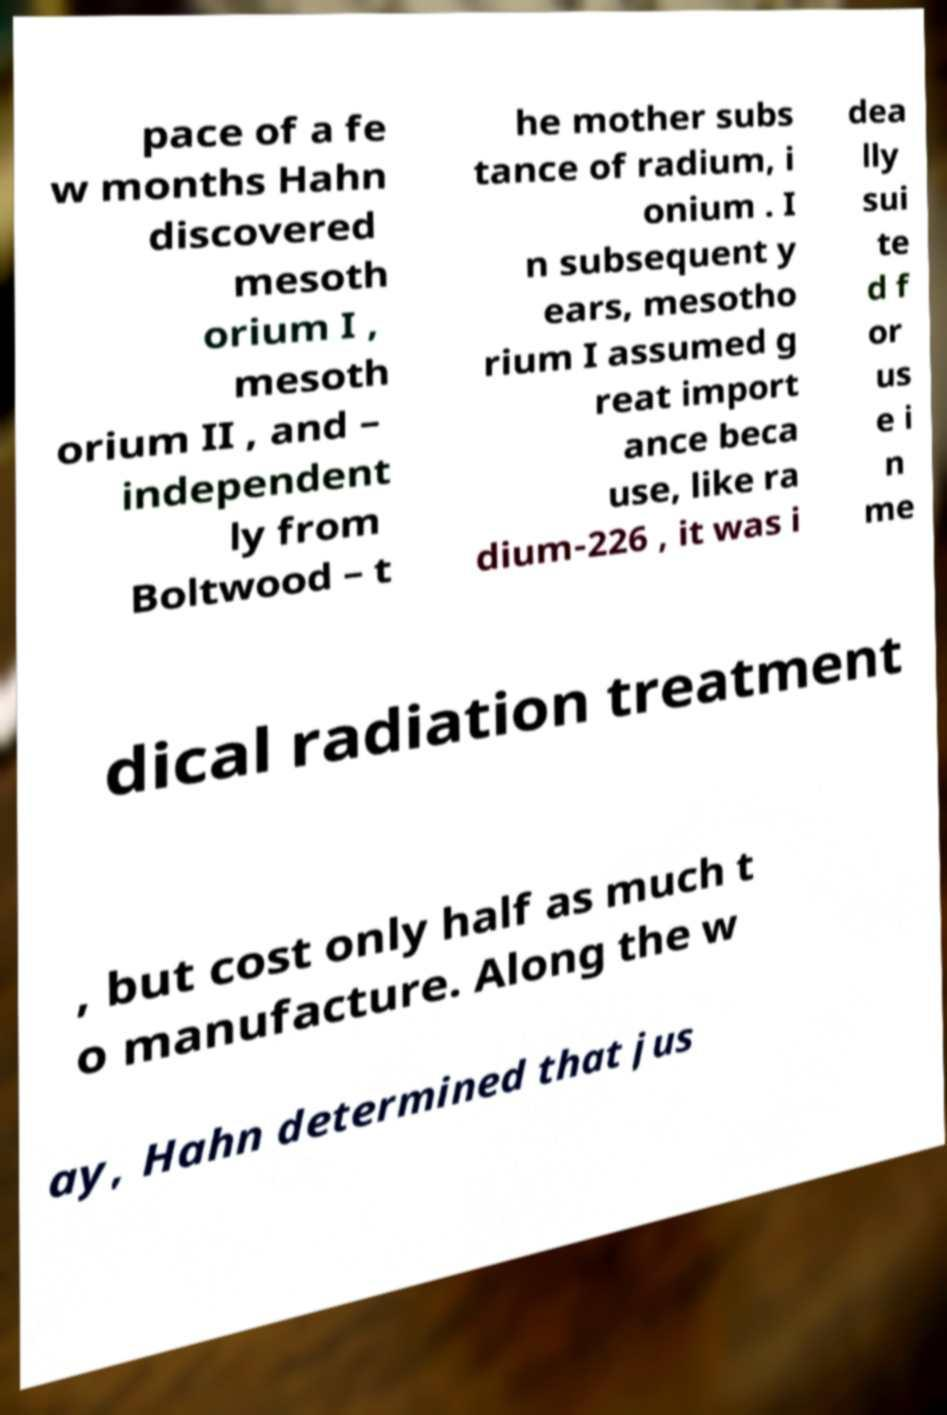Could you assist in decoding the text presented in this image and type it out clearly? pace of a fe w months Hahn discovered mesoth orium I , mesoth orium II , and – independent ly from Boltwood – t he mother subs tance of radium, i onium . I n subsequent y ears, mesotho rium I assumed g reat import ance beca use, like ra dium-226 , it was i dea lly sui te d f or us e i n me dical radiation treatment , but cost only half as much t o manufacture. Along the w ay, Hahn determined that jus 